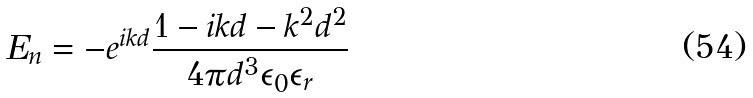<formula> <loc_0><loc_0><loc_500><loc_500>E _ { n } = - e ^ { i k d } \frac { 1 - i k d - k ^ { 2 } d ^ { 2 } } { 4 \pi d ^ { 3 } \epsilon _ { 0 } \epsilon _ { r } }</formula> 